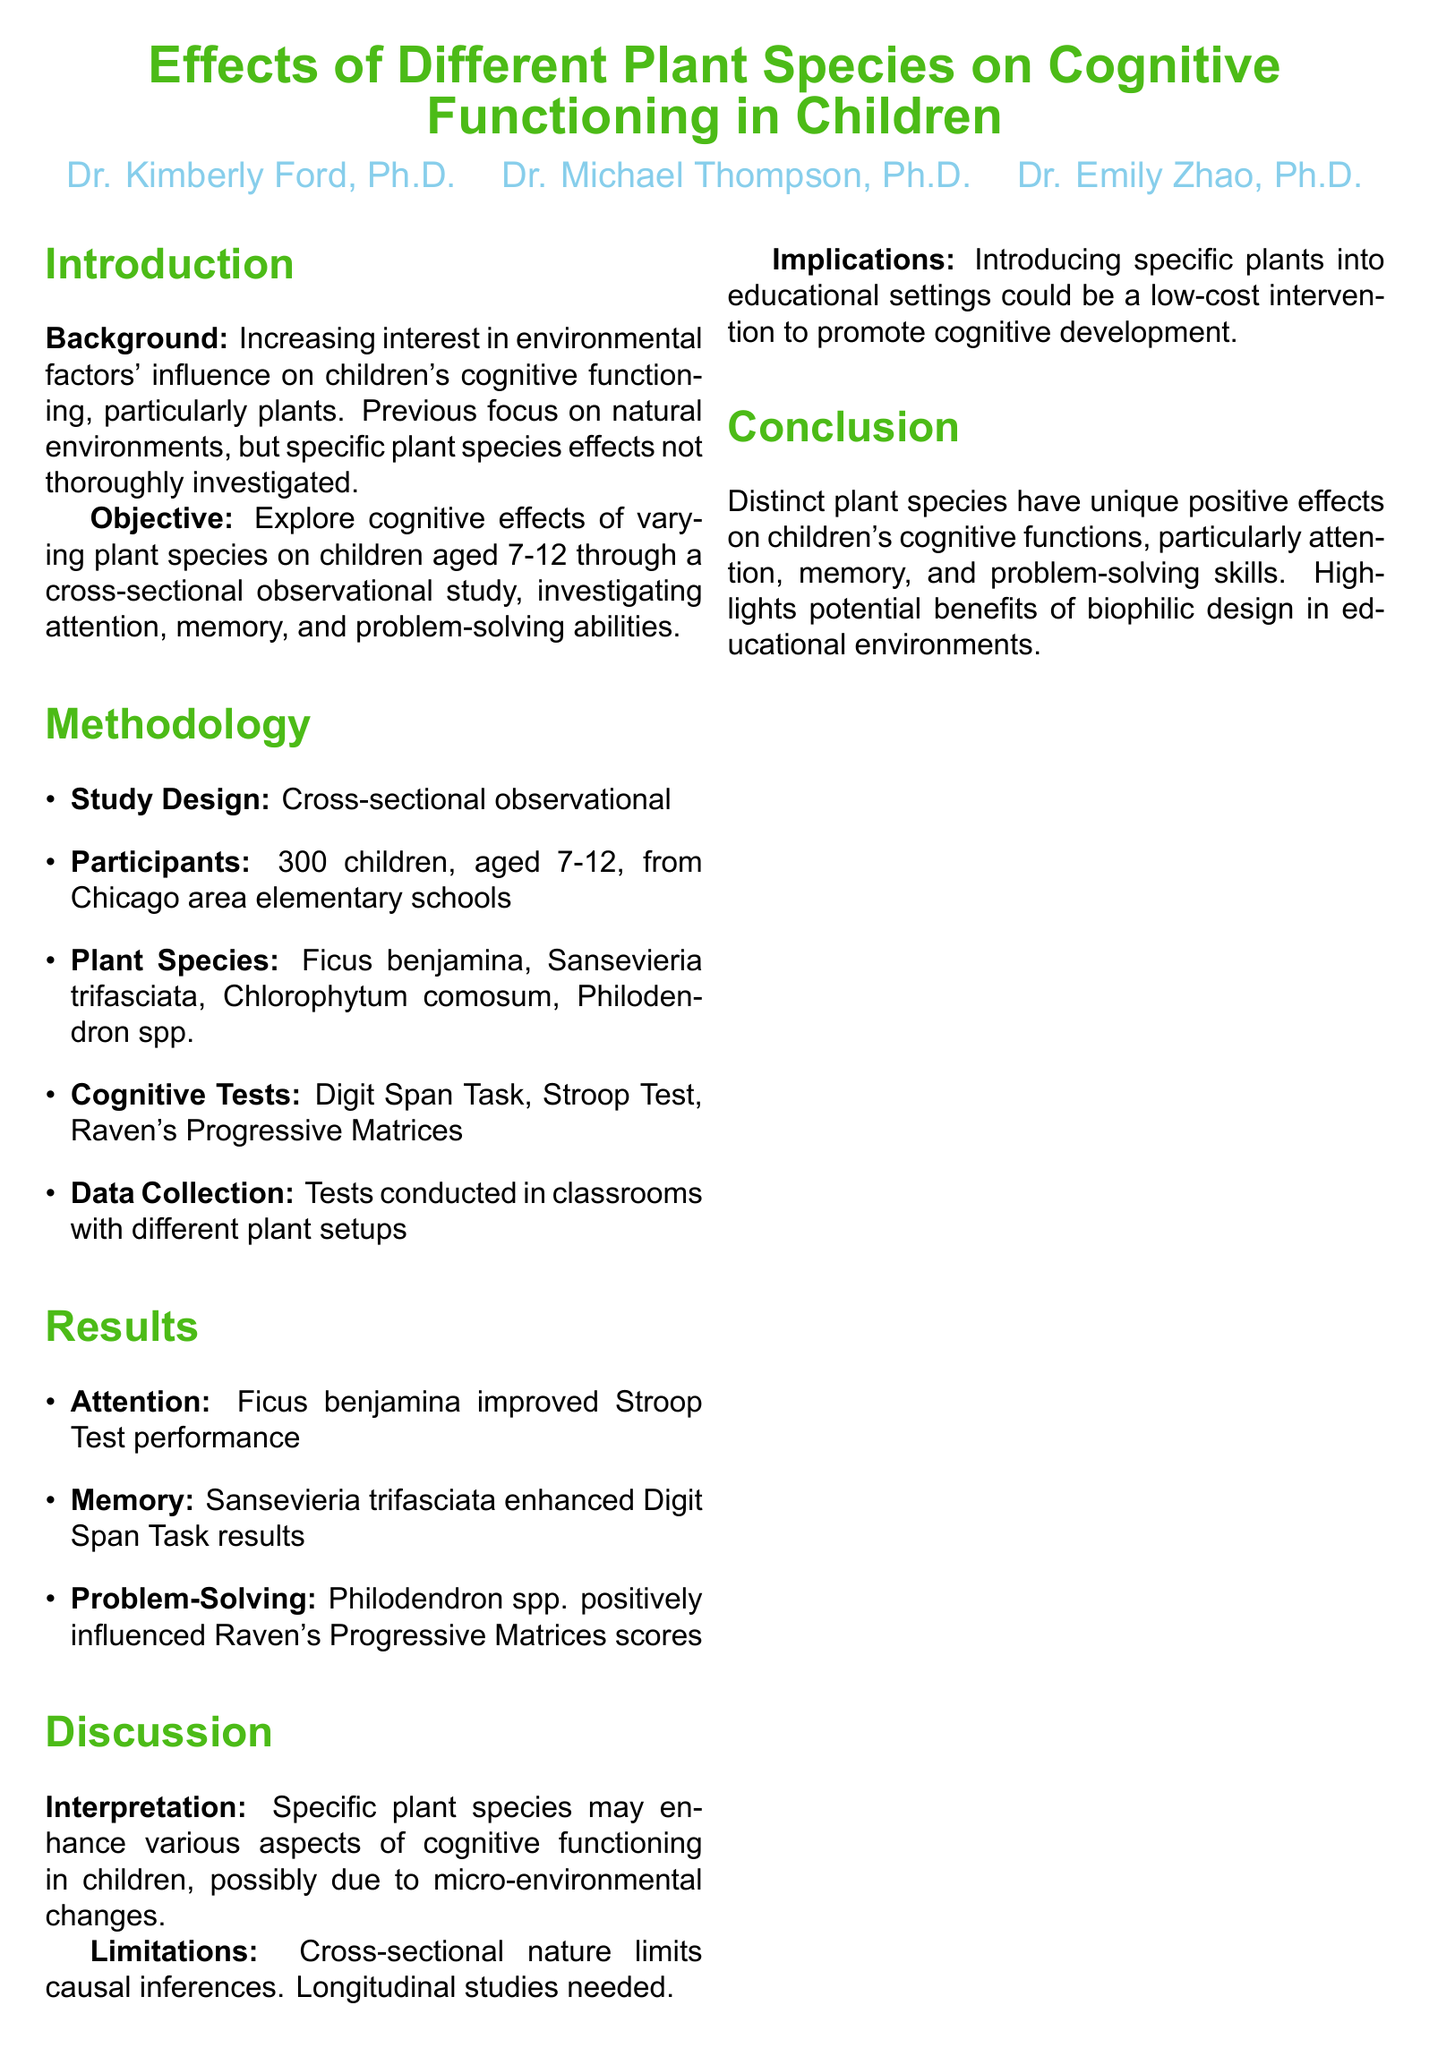What is the total number of participants in the study? The total number of participants is explicitly stated in the document as 300 children.
Answer: 300 children What is the age range of the children involved in the study? The age range is specified under participants as 7-12 years old.
Answer: 7-12 years old Which plant species improved Stroop Test performance? The plant species that improved performance is mentioned in the results section, specifically as Ficus benjamina.
Answer: Ficus benjamina What cognitive test assessed memory? The cognitive test assessing memory is explicitly stated as the Digit Span Task.
Answer: Digit Span Task What limitation is mentioned regarding the study's design? The limitation related to the study's design is noted to be the cross-sectional nature, which limits causal inferences.
Answer: Cross-sectional nature Which funding organization supported this research? The funding organization is stated in the funding section as the National Institute of Mental Health (NIMH).
Answer: National Institute of Mental Health (NIMH) What positive influence did Philodendron spp. have in the study? Philodendron spp. is noted to positively influence Raven's Progressive Matrices scores in the results.
Answer: Raven's Progressive Matrices scores What is the objective of the study? The objective is summarized as exploring cognitive effects of varying plant species on children aged 7-12.
Answer: Exploring cognitive effects of varying plant species on children aged 7-12 What type of study was conducted? The document specifies the study design as cross-sectional observational.
Answer: Cross-sectional observational 